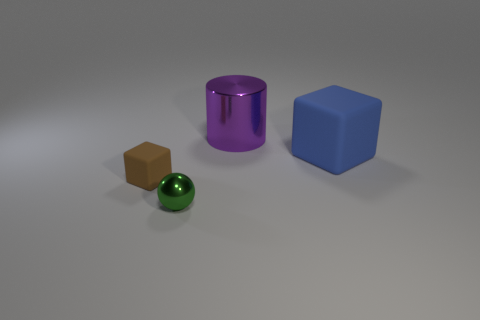Does the block to the left of the purple cylinder have the same material as the blue object?
Make the answer very short. Yes. There is a small thing that is the same shape as the big blue thing; what color is it?
Keep it short and to the point. Brown. How many other objects are there of the same color as the cylinder?
Keep it short and to the point. 0. Is the shape of the metallic object that is left of the purple shiny cylinder the same as the metal object behind the brown thing?
Give a very brief answer. No. How many cylinders are either big things or brown rubber objects?
Your answer should be compact. 1. Is the number of big matte objects on the left side of the large blue thing less than the number of small green spheres?
Your answer should be very brief. Yes. How many other objects are there of the same material as the tiny block?
Ensure brevity in your answer.  1. Is the brown rubber block the same size as the blue thing?
Offer a very short reply. No. How many objects are big objects that are in front of the large purple object or big cylinders?
Your response must be concise. 2. What is the material of the small thing to the right of the object that is on the left side of the ball?
Provide a succinct answer. Metal. 